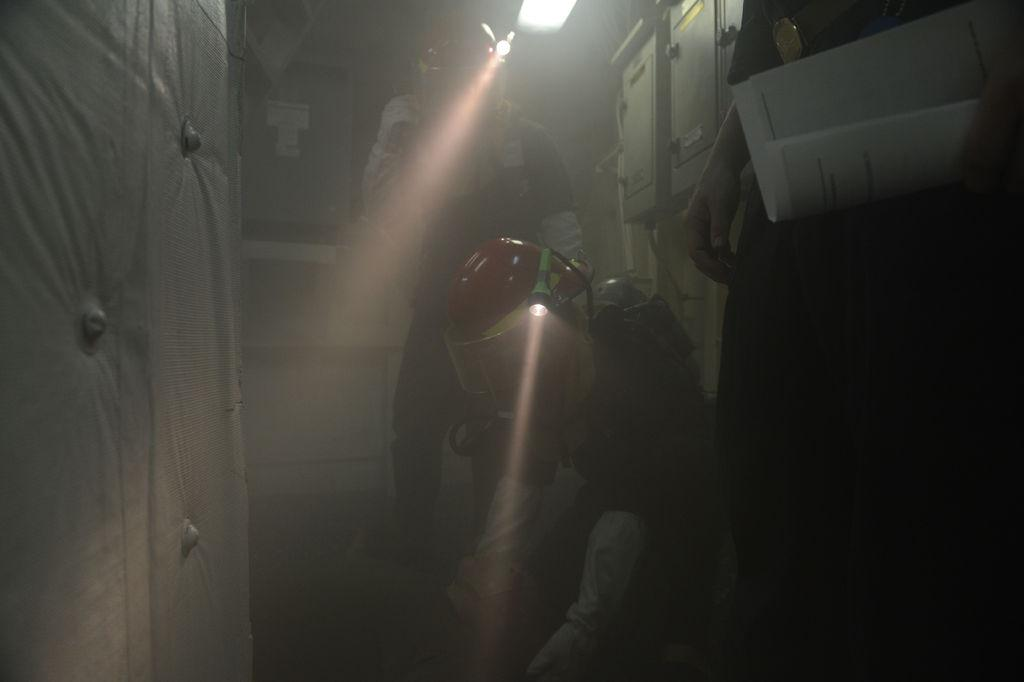How many people are in the image? There are three persons in the image. What are two of the persons wearing? Two of the persons are wearing helmets. What objects can be seen that provide light? There are torches and a light in the image. What is the color of the background in the image? The background of the image is dark. What type of objects can be seen that are typically used for storage or transportation? There are boxes in the image. What type of cracker is being used to light the lamp in the image? There is no cracker or lamp present in the image. How many oranges are visible on the boxes in the image? There are no oranges visible in the image. 